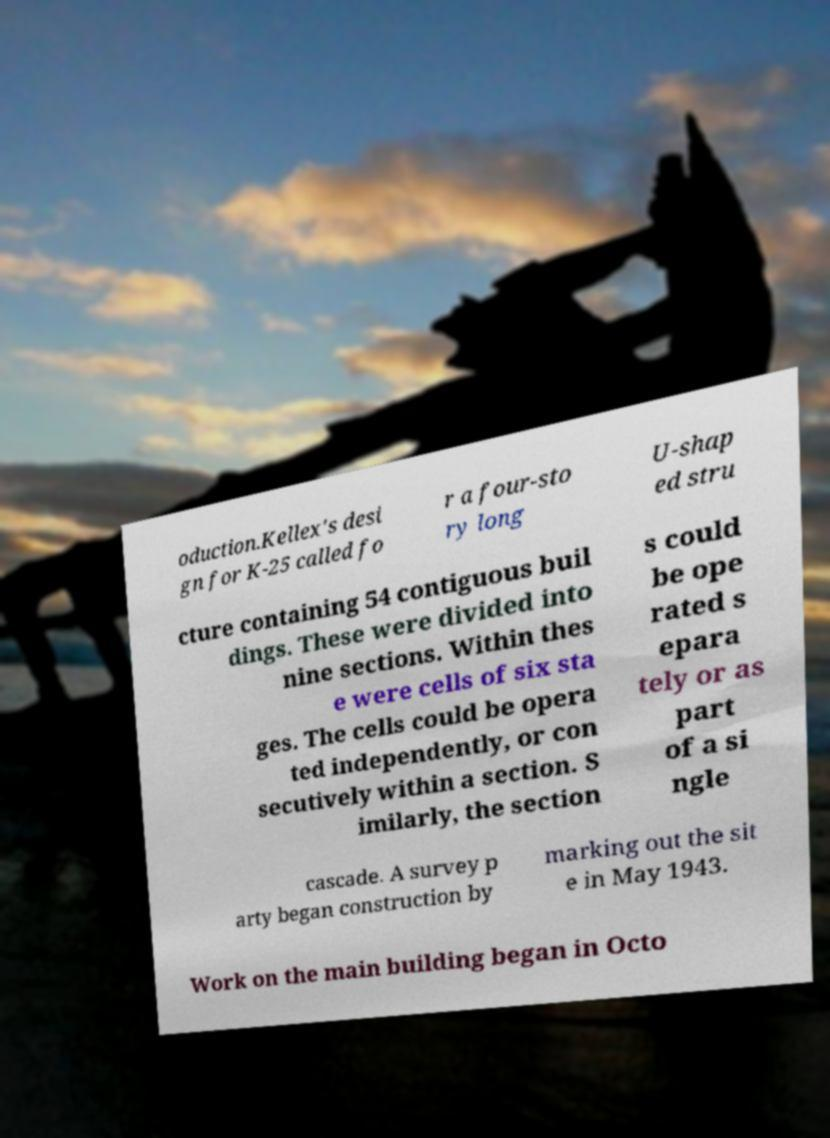For documentation purposes, I need the text within this image transcribed. Could you provide that? oduction.Kellex's desi gn for K-25 called fo r a four-sto ry long U-shap ed stru cture containing 54 contiguous buil dings. These were divided into nine sections. Within thes e were cells of six sta ges. The cells could be opera ted independently, or con secutively within a section. S imilarly, the section s could be ope rated s epara tely or as part of a si ngle cascade. A survey p arty began construction by marking out the sit e in May 1943. Work on the main building began in Octo 